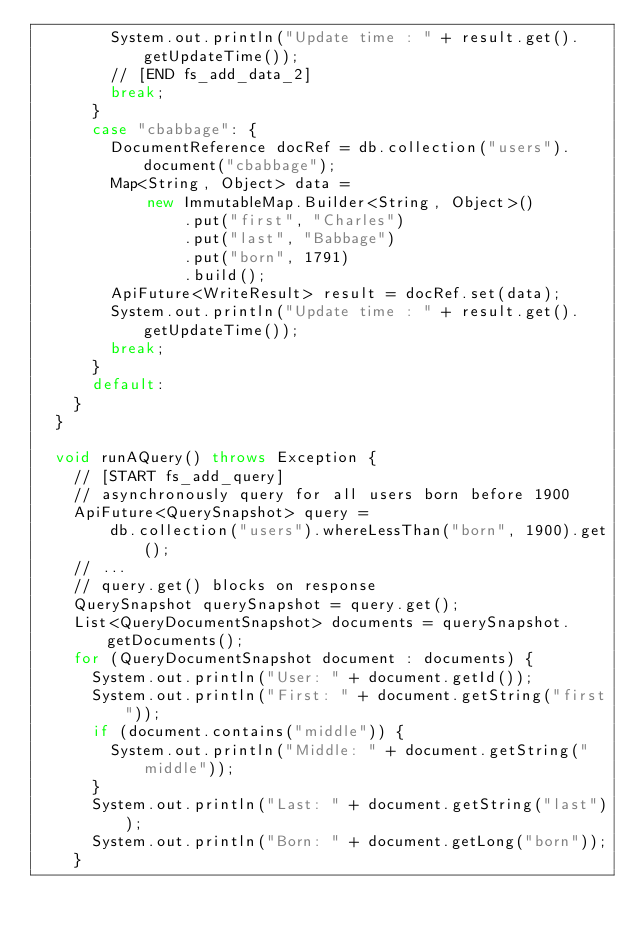<code> <loc_0><loc_0><loc_500><loc_500><_Java_>        System.out.println("Update time : " + result.get().getUpdateTime());
        // [END fs_add_data_2]
        break;
      }
      case "cbabbage": {
        DocumentReference docRef = db.collection("users").document("cbabbage");
        Map<String, Object> data =
            new ImmutableMap.Builder<String, Object>()
                .put("first", "Charles")
                .put("last", "Babbage")
                .put("born", 1791)
                .build();
        ApiFuture<WriteResult> result = docRef.set(data);
        System.out.println("Update time : " + result.get().getUpdateTime());
        break;
      }
      default:
    }
  }

  void runAQuery() throws Exception {
    // [START fs_add_query]
    // asynchronously query for all users born before 1900
    ApiFuture<QuerySnapshot> query =
        db.collection("users").whereLessThan("born", 1900).get();
    // ...
    // query.get() blocks on response
    QuerySnapshot querySnapshot = query.get();
    List<QueryDocumentSnapshot> documents = querySnapshot.getDocuments();
    for (QueryDocumentSnapshot document : documents) {
      System.out.println("User: " + document.getId());
      System.out.println("First: " + document.getString("first"));
      if (document.contains("middle")) {
        System.out.println("Middle: " + document.getString("middle"));
      }
      System.out.println("Last: " + document.getString("last"));
      System.out.println("Born: " + document.getLong("born"));
    }</code> 